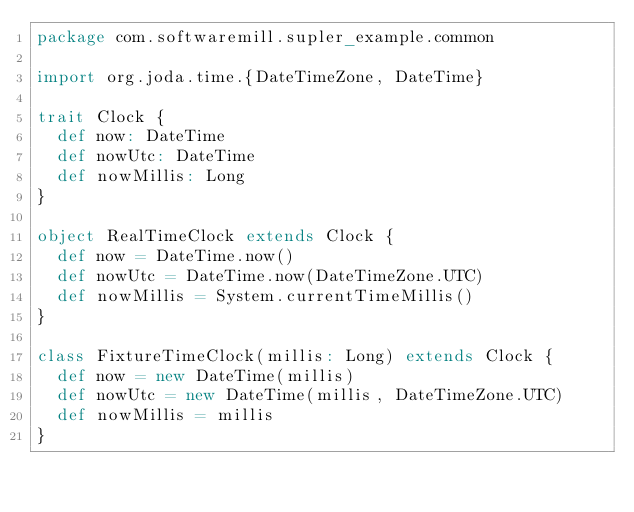Convert code to text. <code><loc_0><loc_0><loc_500><loc_500><_Scala_>package com.softwaremill.supler_example.common

import org.joda.time.{DateTimeZone, DateTime}

trait Clock {
  def now: DateTime
  def nowUtc: DateTime
  def nowMillis: Long
}

object RealTimeClock extends Clock {
  def now = DateTime.now()
  def nowUtc = DateTime.now(DateTimeZone.UTC)
  def nowMillis = System.currentTimeMillis()
}

class FixtureTimeClock(millis: Long) extends Clock {
  def now = new DateTime(millis)
  def nowUtc = new DateTime(millis, DateTimeZone.UTC)
  def nowMillis = millis
}
</code> 